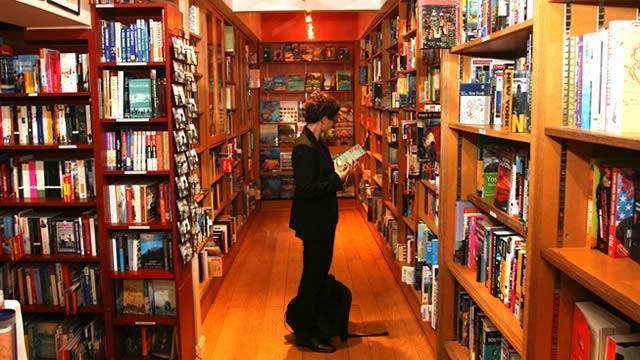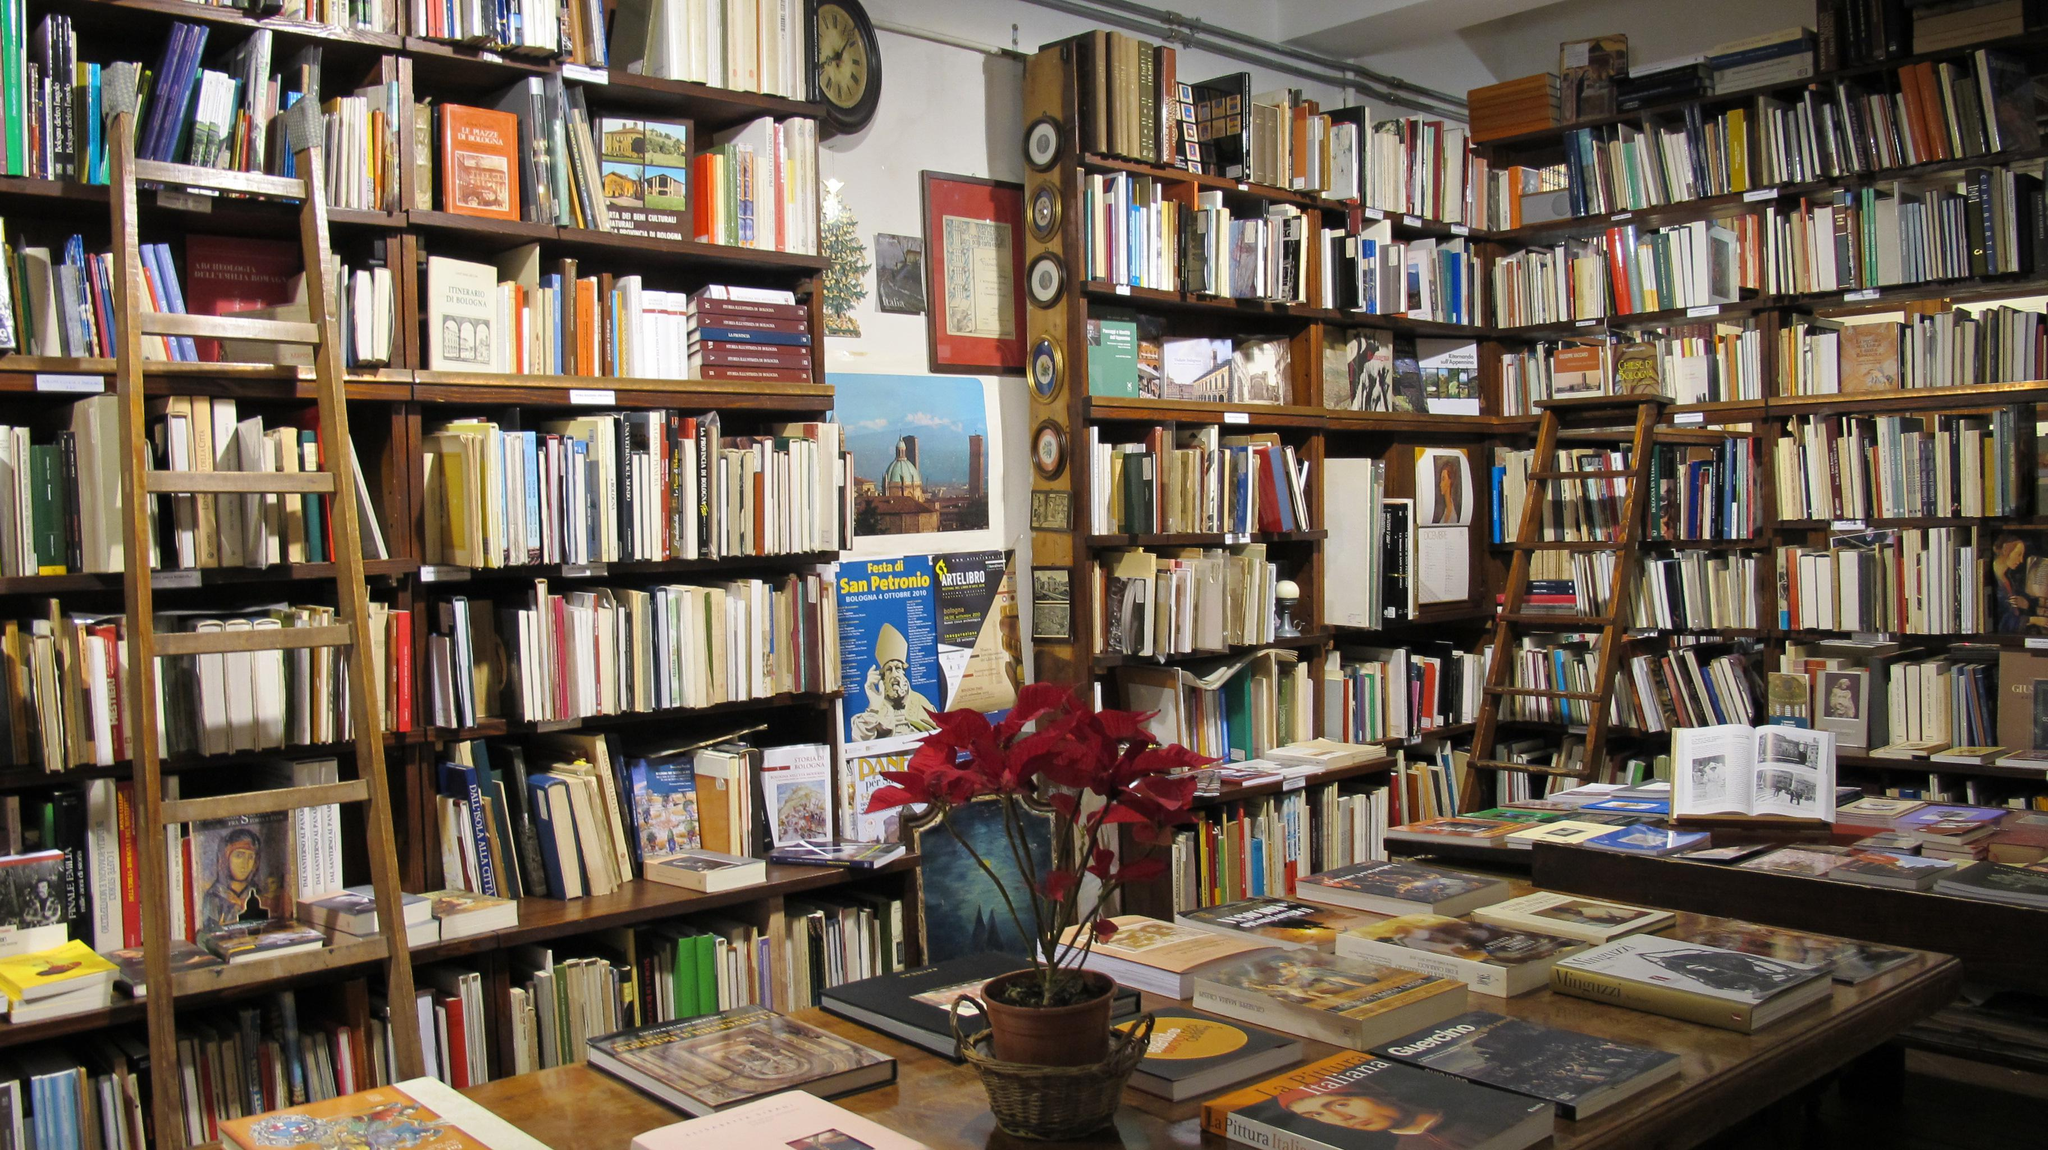The first image is the image on the left, the second image is the image on the right. Considering the images on both sides, is "There is at least one person in the image on the left." valid? Answer yes or no. Yes. 